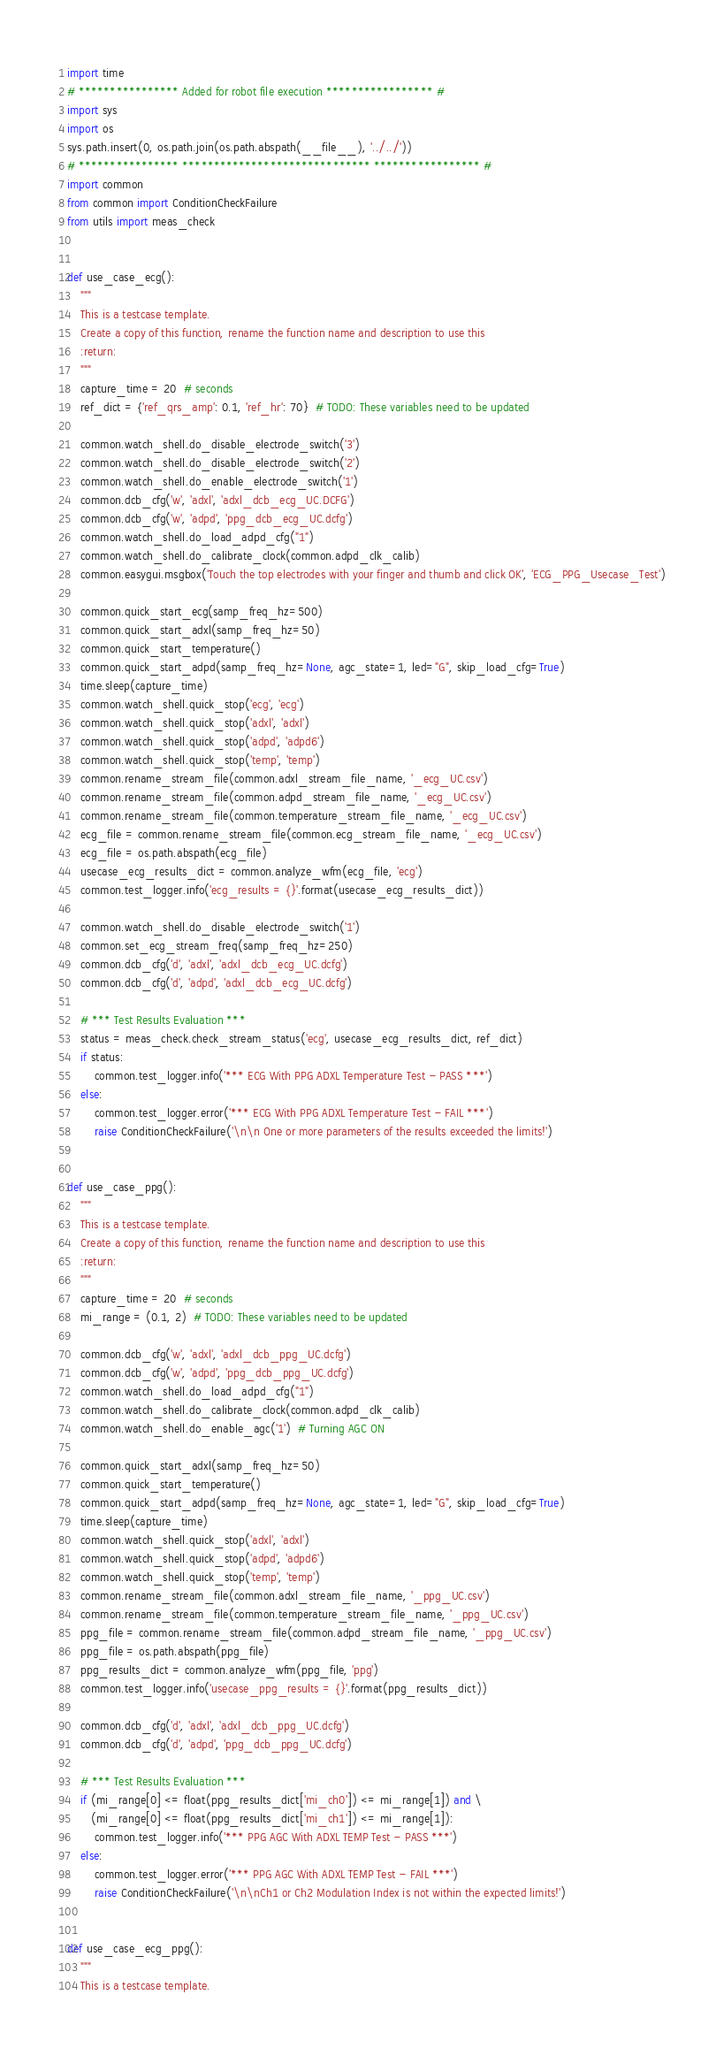<code> <loc_0><loc_0><loc_500><loc_500><_Python_>import time
# **************** Added for robot file execution ***************** #
import sys
import os
sys.path.insert(0, os.path.join(os.path.abspath(__file__), '../../'))
# **************** ****************************** ***************** #
import common
from common import ConditionCheckFailure
from utils import meas_check


def use_case_ecg():
    """
    This is a testcase template.
    Create a copy of this function, rename the function name and description to use this
    :return:
    """
    capture_time = 20  # seconds
    ref_dict = {'ref_qrs_amp': 0.1, 'ref_hr': 70}  # TODO: These variables need to be updated

    common.watch_shell.do_disable_electrode_switch('3')
    common.watch_shell.do_disable_electrode_switch('2')
    common.watch_shell.do_enable_electrode_switch('1')
    common.dcb_cfg('w', 'adxl', 'adxl_dcb_ecg_UC.DCFG')
    common.dcb_cfg('w', 'adpd', 'ppg_dcb_ecg_UC.dcfg')
    common.watch_shell.do_load_adpd_cfg("1")
    common.watch_shell.do_calibrate_clock(common.adpd_clk_calib)
    common.easygui.msgbox('Touch the top electrodes with your finger and thumb and click OK', 'ECG_PPG_Usecase_Test')

    common.quick_start_ecg(samp_freq_hz=500)
    common.quick_start_adxl(samp_freq_hz=50)
    common.quick_start_temperature()
    common.quick_start_adpd(samp_freq_hz=None, agc_state=1, led="G", skip_load_cfg=True)
    time.sleep(capture_time)
    common.watch_shell.quick_stop('ecg', 'ecg')
    common.watch_shell.quick_stop('adxl', 'adxl')
    common.watch_shell.quick_stop('adpd', 'adpd6')
    common.watch_shell.quick_stop('temp', 'temp')
    common.rename_stream_file(common.adxl_stream_file_name, '_ecg_UC.csv')
    common.rename_stream_file(common.adpd_stream_file_name, '_ecg_UC.csv')
    common.rename_stream_file(common.temperature_stream_file_name, '_ecg_UC.csv')
    ecg_file = common.rename_stream_file(common.ecg_stream_file_name, '_ecg_UC.csv')
    ecg_file = os.path.abspath(ecg_file)
    usecase_ecg_results_dict = common.analyze_wfm(ecg_file, 'ecg')
    common.test_logger.info('ecg_results = {}'.format(usecase_ecg_results_dict))

    common.watch_shell.do_disable_electrode_switch('1')
    common.set_ecg_stream_freq(samp_freq_hz=250)
    common.dcb_cfg('d', 'adxl', 'adxl_dcb_ecg_UC.dcfg')
    common.dcb_cfg('d', 'adpd', 'adxl_dcb_ecg_UC.dcfg')

    # *** Test Results Evaluation ***
    status = meas_check.check_stream_status('ecg', usecase_ecg_results_dict, ref_dict)
    if status:
        common.test_logger.info('*** ECG With PPG ADXL Temperature Test - PASS ***')
    else:
        common.test_logger.error('*** ECG With PPG ADXL Temperature Test - FAIL ***')
        raise ConditionCheckFailure('\n\n One or more parameters of the results exceeded the limits!')


def use_case_ppg():
    """
    This is a testcase template.
    Create a copy of this function, rename the function name and description to use this
    :return:
    """
    capture_time = 20  # seconds
    mi_range = (0.1, 2)  # TODO: These variables need to be updated

    common.dcb_cfg('w', 'adxl', 'adxl_dcb_ppg_UC.dcfg')
    common.dcb_cfg('w', 'adpd', 'ppg_dcb_ppg_UC.dcfg')
    common.watch_shell.do_load_adpd_cfg("1")
    common.watch_shell.do_calibrate_clock(common.adpd_clk_calib)
    common.watch_shell.do_enable_agc('1')  # Turning AGC ON

    common.quick_start_adxl(samp_freq_hz=50)
    common.quick_start_temperature()
    common.quick_start_adpd(samp_freq_hz=None, agc_state=1, led="G", skip_load_cfg=True)
    time.sleep(capture_time)
    common.watch_shell.quick_stop('adxl', 'adxl')
    common.watch_shell.quick_stop('adpd', 'adpd6')
    common.watch_shell.quick_stop('temp', 'temp')
    common.rename_stream_file(common.adxl_stream_file_name, '_ppg_UC.csv')
    common.rename_stream_file(common.temperature_stream_file_name, '_ppg_UC.csv')
    ppg_file = common.rename_stream_file(common.adpd_stream_file_name, '_ppg_UC.csv')
    ppg_file = os.path.abspath(ppg_file)
    ppg_results_dict = common.analyze_wfm(ppg_file, 'ppg')
    common.test_logger.info('usecase_ppg_results = {}'.format(ppg_results_dict))

    common.dcb_cfg('d', 'adxl', 'adxl_dcb_ppg_UC.dcfg')
    common.dcb_cfg('d', 'adpd', 'ppg_dcb_ppg_UC.dcfg')

    # *** Test Results Evaluation ***
    if (mi_range[0] <= float(ppg_results_dict['mi_ch0']) <= mi_range[1]) and \
       (mi_range[0] <= float(ppg_results_dict['mi_ch1']) <= mi_range[1]):
        common.test_logger.info('*** PPG AGC With ADXL TEMP Test - PASS ***')
    else:
        common.test_logger.error('*** PPG AGC With ADXL TEMP Test - FAIL ***')
        raise ConditionCheckFailure('\n\nCh1 or Ch2 Modulation Index is not within the expected limits!')


def use_case_ecg_ppg():
    """
    This is a testcase template.</code> 